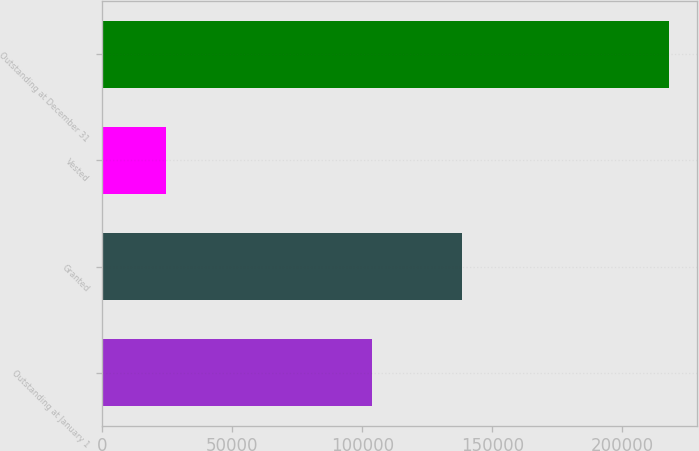<chart> <loc_0><loc_0><loc_500><loc_500><bar_chart><fcel>Outstanding at January 1<fcel>Granted<fcel>Vested<fcel>Outstanding at December 31<nl><fcel>103800<fcel>138500<fcel>24480<fcel>217820<nl></chart> 